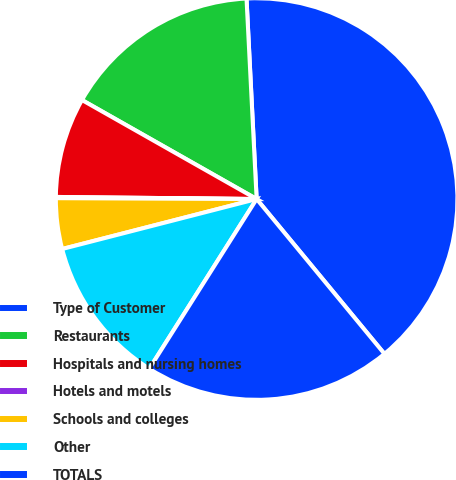Convert chart to OTSL. <chart><loc_0><loc_0><loc_500><loc_500><pie_chart><fcel>Type of Customer<fcel>Restaurants<fcel>Hospitals and nursing homes<fcel>Hotels and motels<fcel>Schools and colleges<fcel>Other<fcel>TOTALS<nl><fcel>39.82%<fcel>15.99%<fcel>8.04%<fcel>0.1%<fcel>4.07%<fcel>12.02%<fcel>19.96%<nl></chart> 